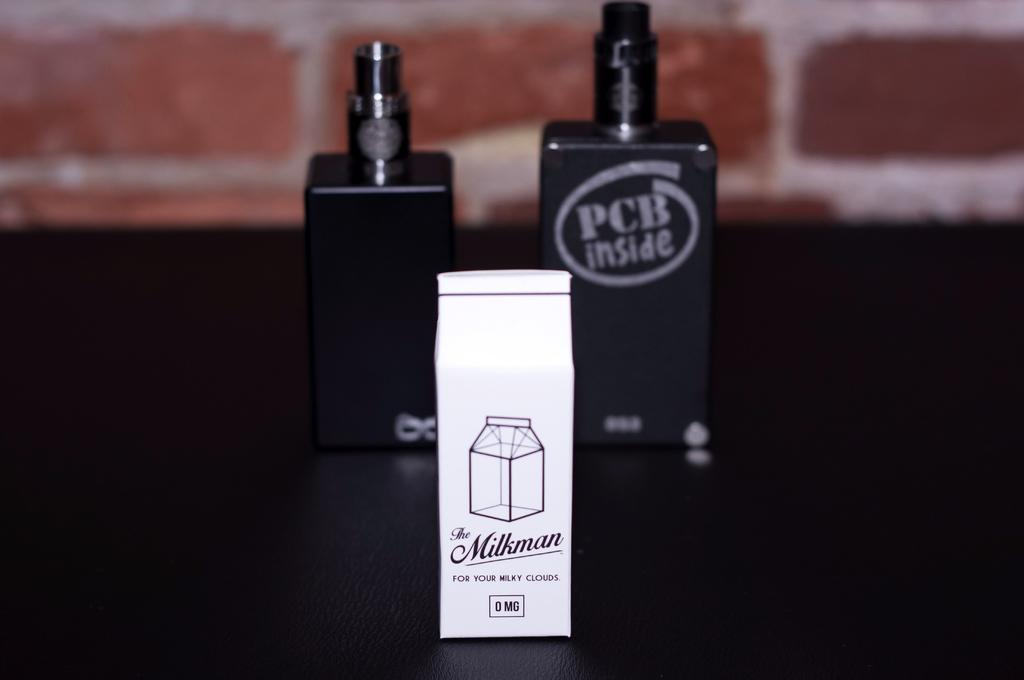<image>
Give a short and clear explanation of the subsequent image. Black perfume bottles behind a white package made my The Milkman. 